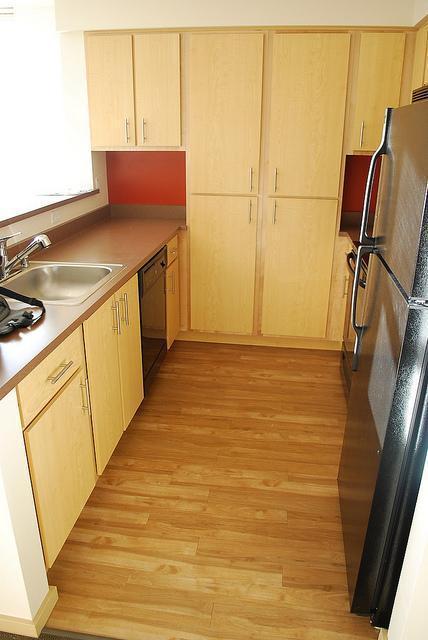How many sinks are in the photo?
Give a very brief answer. 1. 